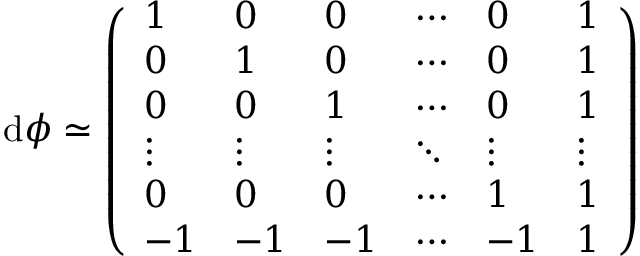<formula> <loc_0><loc_0><loc_500><loc_500>d \phi \simeq \left ( \begin{array} { l l l l l l } { 1 } & { 0 } & { 0 } & { \cdots } & { 0 } & { 1 } \\ { 0 } & { 1 } & { 0 } & { \cdots } & { 0 } & { 1 } \\ { 0 } & { 0 } & { 1 } & { \cdots } & { 0 } & { 1 } \\ { \vdots } & { \vdots } & { \vdots } & { \ddots } & { \vdots } & { \vdots } \\ { 0 } & { 0 } & { 0 } & { \cdots } & { 1 } & { 1 } \\ { - 1 } & { - 1 } & { - 1 } & { \cdots } & { - 1 } & { 1 } \end{array} \right )</formula> 